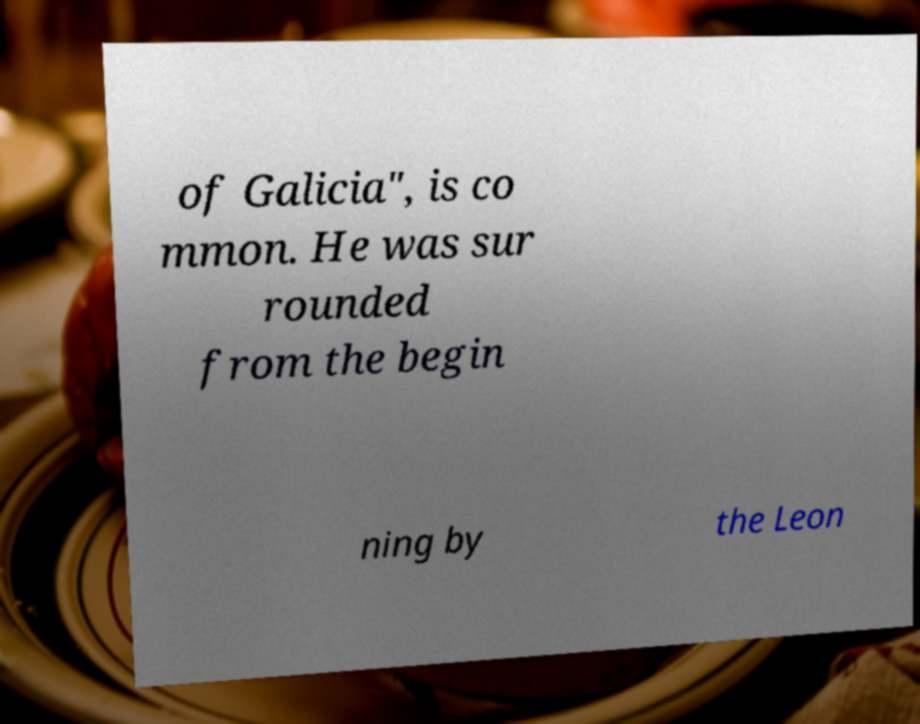Could you assist in decoding the text presented in this image and type it out clearly? of Galicia", is co mmon. He was sur rounded from the begin ning by the Leon 